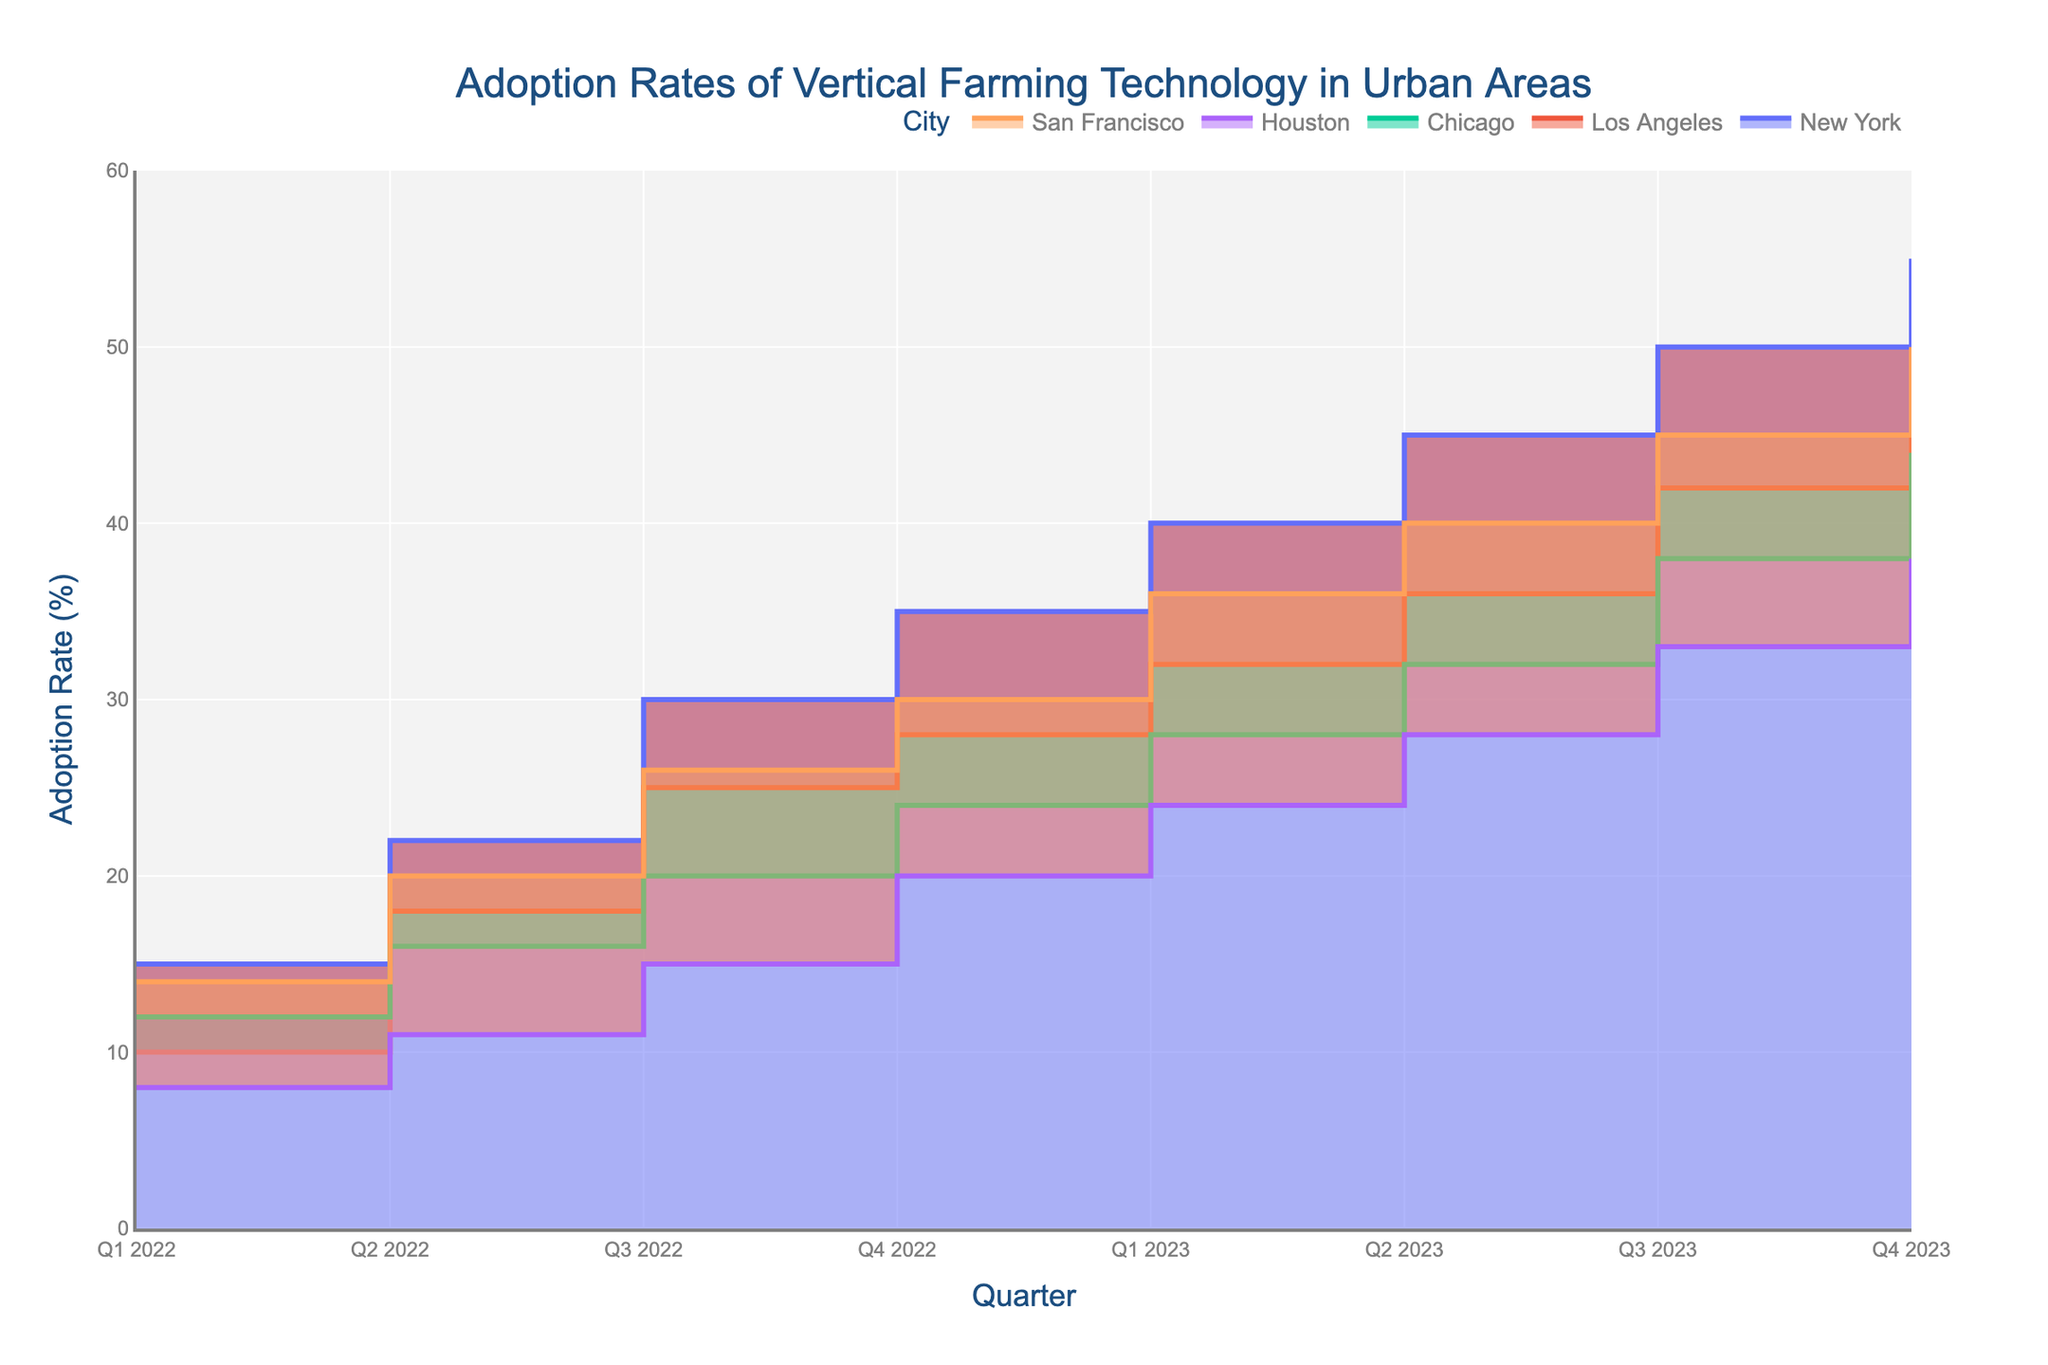What is the title of the chart? The title is usually displayed at the top of the chart, and it typically summarizes what the chart represents. In this case, the title reads 'Adoption Rates of Vertical Farming Technology in Urban Areas'.
Answer: Adoption Rates of Vertical Farming Technology in Urban Areas Which city has the highest adoption rate in Q4 2023? Look at the data points for Q4 2023 in the chart. Identify which city's adoption rate is the highest by comparing the endpoints of the step areas for that quarter. New York has an adoption rate of 55%, which is the highest.
Answer: New York How did Chicago's adoption rate change from Q1 2022 to Q4 2023? Observe the data points for Chicago at Q1 2022 and Q4 2023. Note the initial and final values (12% and 44%, respectively). The change can be calculated as 44% - 12%.
Answer: Increased by 32% Which quarter saw the largest overall increase in the adoption rate for San Francisco? Calculate the difference in adoption rates for each consecutive quarter for San Francisco and identify the quarter with the highest increase. From Q1 2023 to Q2 2023, the rate increased by 4%, which is the largest jump.
Answer: Q1 2023 to Q2 2023 Among the cities, which one had the lowest adoption rate in Q1 2022? Examine the Q1 2022 data points for all cities. Identify the city with the lowest adoption rate (Houston at 8%).
Answer: Houston Compare the adoption rates of New York and Los Angeles in Q3 2023. Which was higher and by how much? Check the adoption rates of New York and Los Angeles in Q3 2023. New York's rate was 50% while Los Angeles' rate was 42%. The difference is 50% - 42%.
Answer: New York by 8% What is the average adoption rate for Houston across all quarters shown in the chart? Sum the adoption rates for Houston across all quarters and divide by the number of quarters (8). (8 + 11 + 15 + 20 + 24 + 28 + 33 + 38)/8 = 21.125%.
Answer: 21.125% Which city showed a consistent increase in adoption rates across all quarters from Q1 2022 to Q4 2023? Observe the trends for all cities; identify which city's adoption rates never decreased across all quarters. New York's rates consistently increased from every quarter to the next.
Answer: New York Was there any quarter where the adoption rate of vertical farming technology decreased for any city? Investigate if any city has a lower adoption rate in a later quarter compared to an earlier one; all cities show a steady or increasing trend, hence there are no decreases.
Answer: No What can you infer about the overall trend of vertical farming technology adoption in urban areas from Q1 2022 to Q4 2023? Review the general direction of the adoption rates for all cities over the given quarters. All show an upward trend, indicating increasing adoption rates over time.
Answer: Increasing trend 